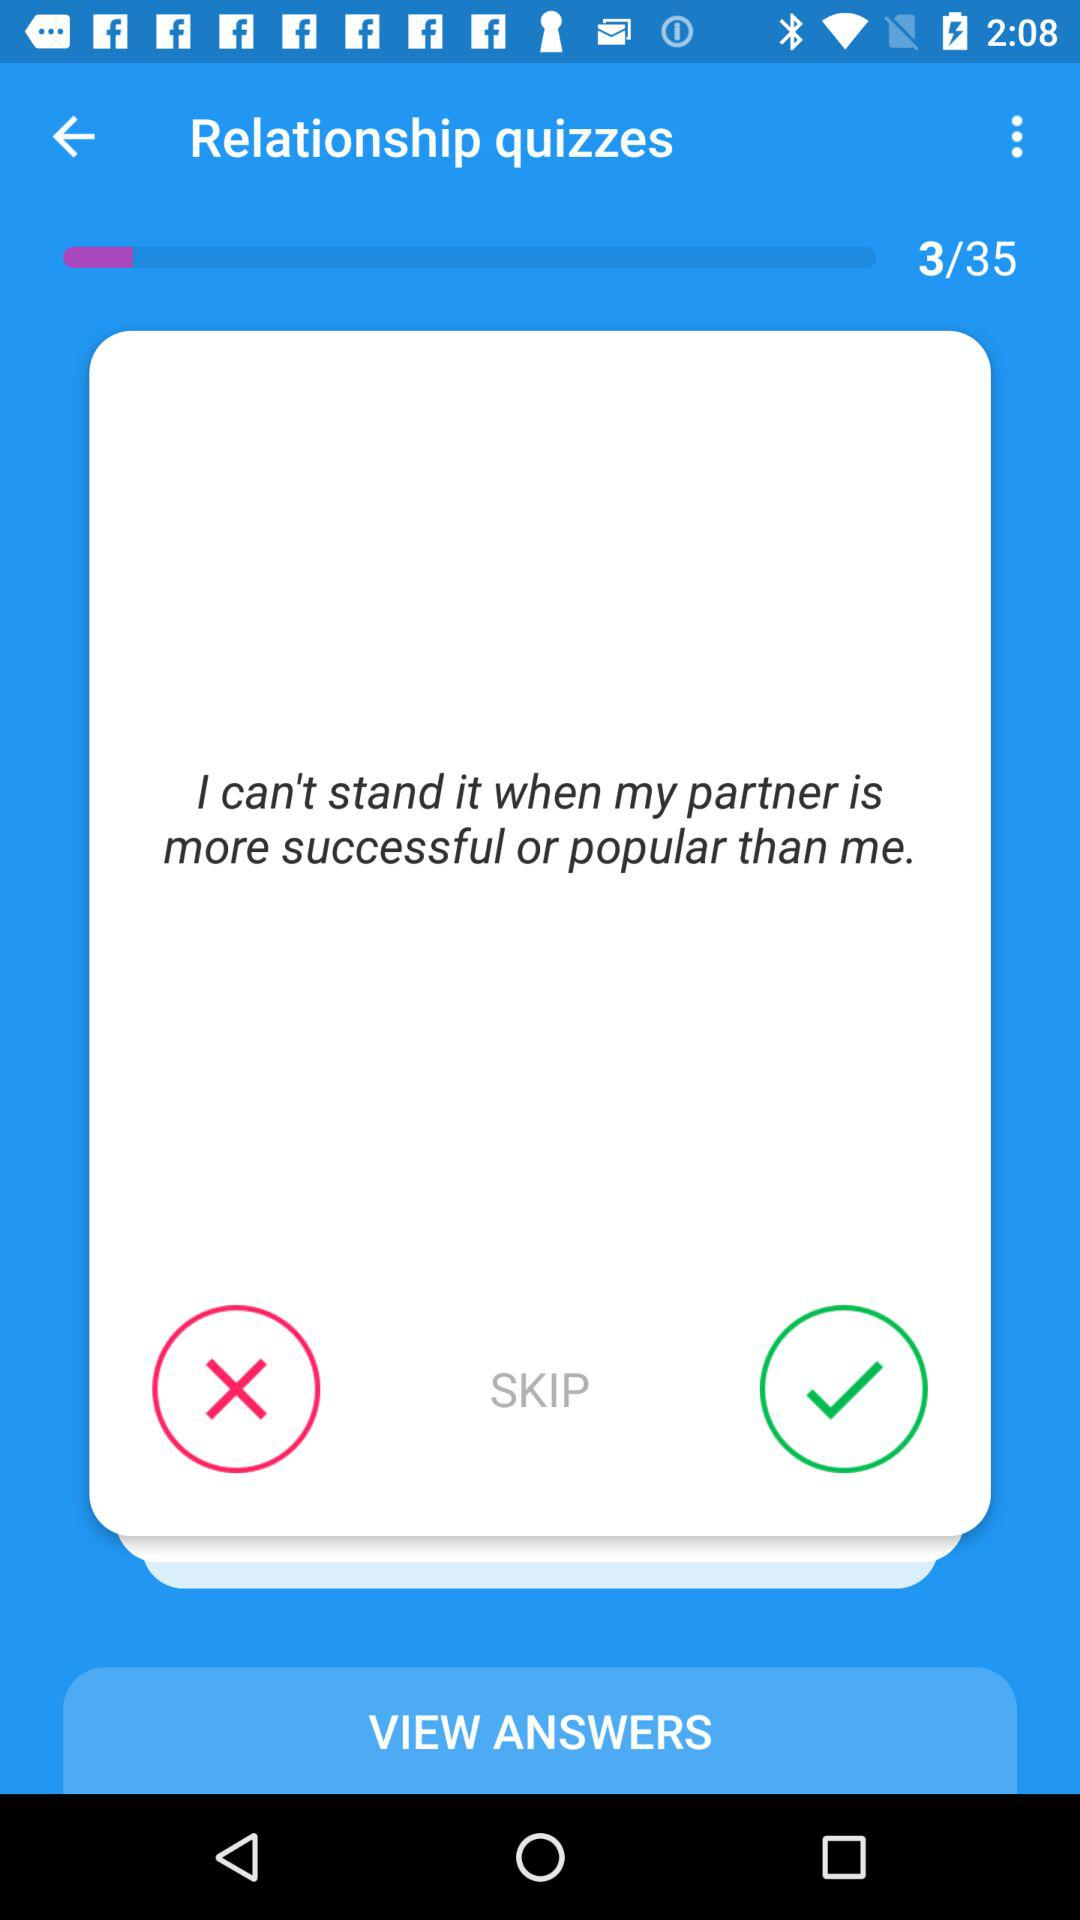How many more questions are there in the quiz than the current question number?
Answer the question using a single word or phrase. 32 